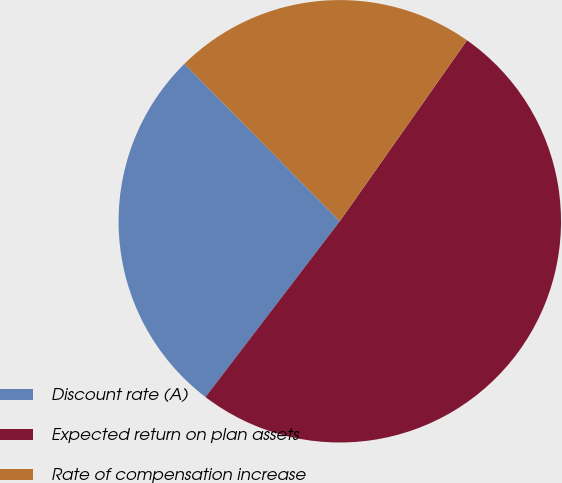Convert chart. <chart><loc_0><loc_0><loc_500><loc_500><pie_chart><fcel>Discount rate (A)<fcel>Expected return on plan assets<fcel>Rate of compensation increase<nl><fcel>27.22%<fcel>50.63%<fcel>22.15%<nl></chart> 